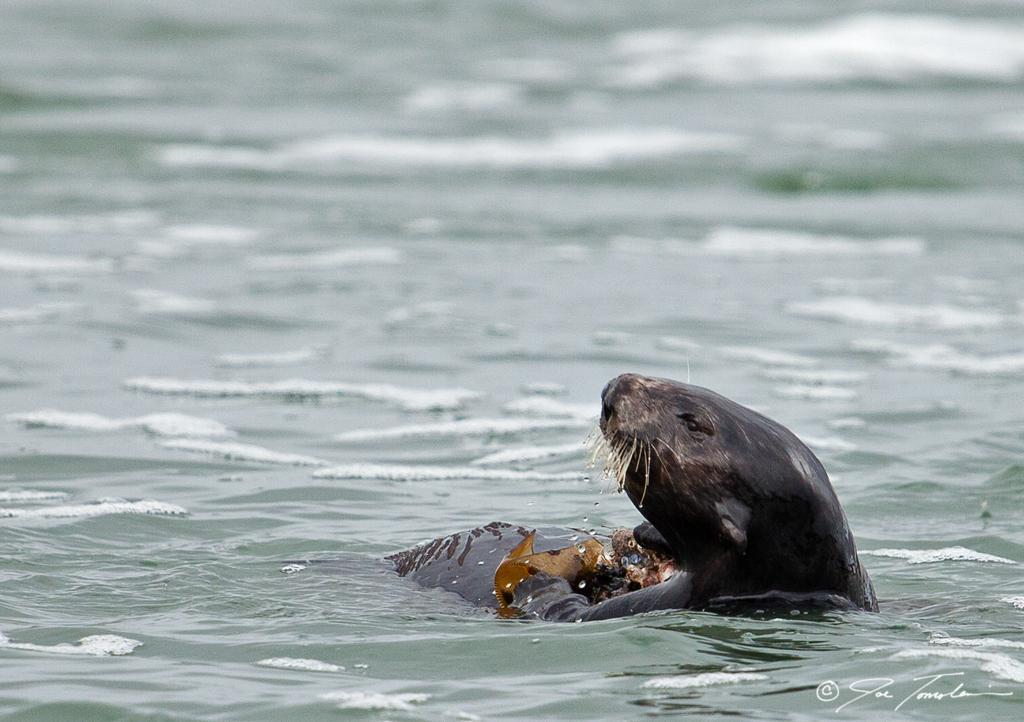Can you describe this image briefly? In this image I can see an animal in the water. Here I can see a watermark on the image. 